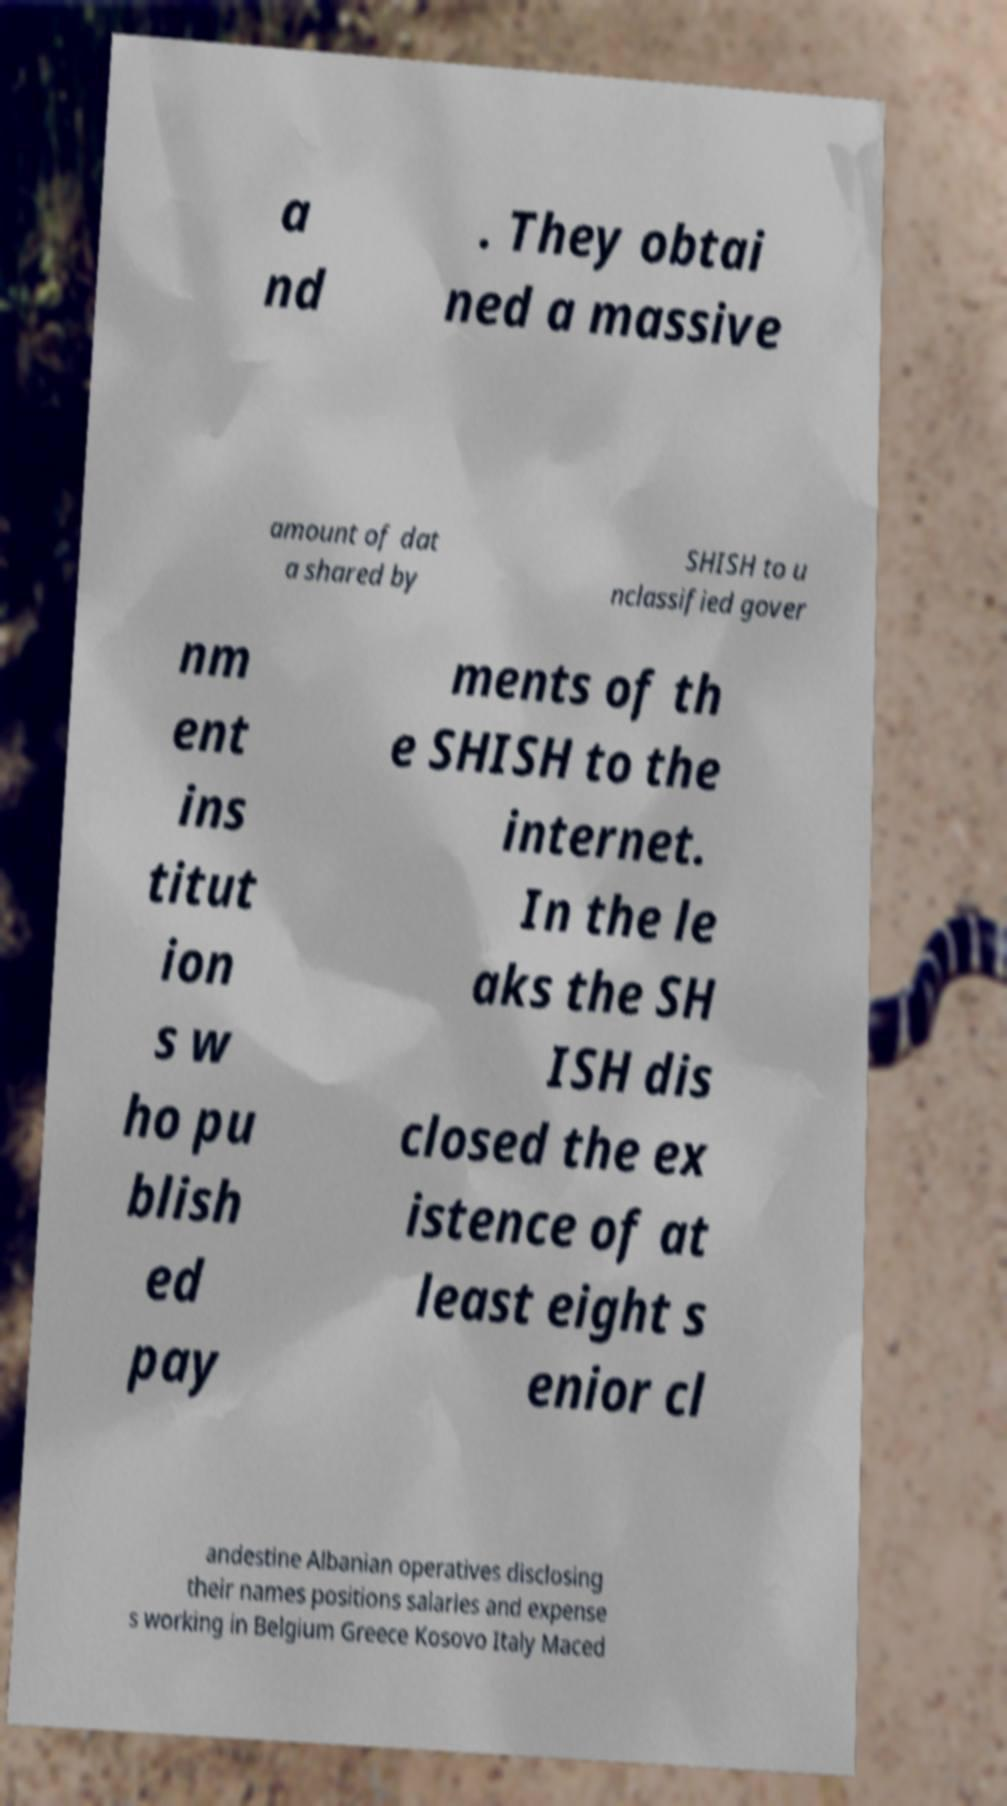I need the written content from this picture converted into text. Can you do that? a nd . They obtai ned a massive amount of dat a shared by SHISH to u nclassified gover nm ent ins titut ion s w ho pu blish ed pay ments of th e SHISH to the internet. In the le aks the SH ISH dis closed the ex istence of at least eight s enior cl andestine Albanian operatives disclosing their names positions salaries and expense s working in Belgium Greece Kosovo Italy Maced 